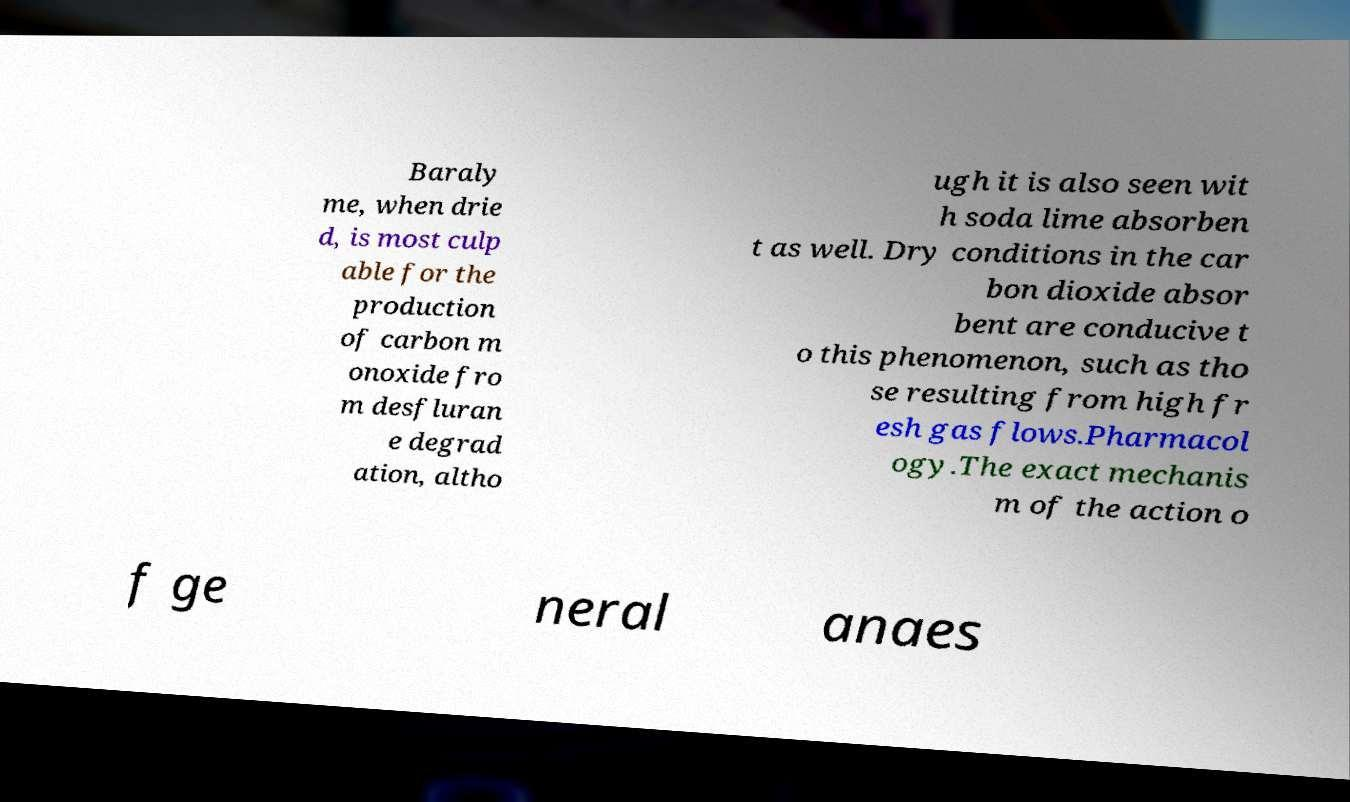Please read and relay the text visible in this image. What does it say? Baraly me, when drie d, is most culp able for the production of carbon m onoxide fro m desfluran e degrad ation, altho ugh it is also seen wit h soda lime absorben t as well. Dry conditions in the car bon dioxide absor bent are conducive t o this phenomenon, such as tho se resulting from high fr esh gas flows.Pharmacol ogy.The exact mechanis m of the action o f ge neral anaes 